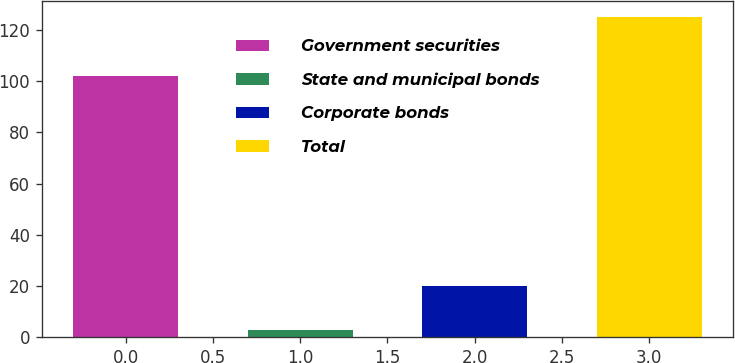Convert chart to OTSL. <chart><loc_0><loc_0><loc_500><loc_500><bar_chart><fcel>Government securities<fcel>State and municipal bonds<fcel>Corporate bonds<fcel>Total<nl><fcel>102<fcel>3<fcel>20<fcel>125<nl></chart> 